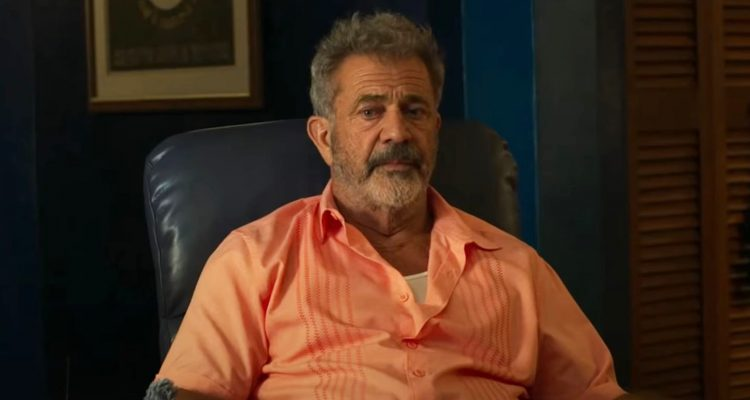If this character could tell one story, what would it be? If the character could tell one story, it would likely be a tale of perseverance and passion. He might share the story of a pivotal moment in his career when he faced significant challenges but chose to push through despite the obstacles. He would recount the countless nights spent grading papers, the students whose lives he touched, and the one book that changed his perspective on both teaching and life itself. This book, he would reveal, was not just a piece of literature but a catalyst for his transformation as an educator and a human being. His story would be one of unwavering commitment to his craft, the joy of discovery in guiding others, and the satisfaction of knowing that his contributions made a real difference. If this room could transform into a different setting, where would it be? Imagine this room magically transforming into a serene lakeside cabin. The blue leather chair now faces a large window overlooking a tranquil lake, framed by tall evergreen trees. The walls are replaced with rustic logs, adding to the natural charm. The framed certificate is now a colorful painting of a sunset over the water, and the wooden bookshelf holds various nature guides and fishing gear. The louvered wooden door opens to a small balcony with a couple of wooden rocking chairs, perfect for enjoying the peaceful morning mist or the vibrant colors of dusk. This lakeside retreat becomes a sanctuary of calm, where the character can find inspiration in the beauty of nature and the simplicity of life. What advice might this character offer to someone at a crossroads in life? The character would likely offer sage advice derived from his years of experience and contemplation. He might suggest to take a moment to reflect on what truly matters to you, beyond the expectations and pressures imposed by others. Consider your passions and what draws you naturally, as these are often indicators of your true calling. He would emphasize the importance of perseverance and not being afraid to take risks or make changes, even when the path is unclear. The character would remind you to seek wisdom from mentors and find strength in the support of friends and family, as life's most challenging moments often lead to the most significant growth. Trust in your journey, he would say, and know that every step, even those that seem uncertain, contributes to the person you are becoming. 